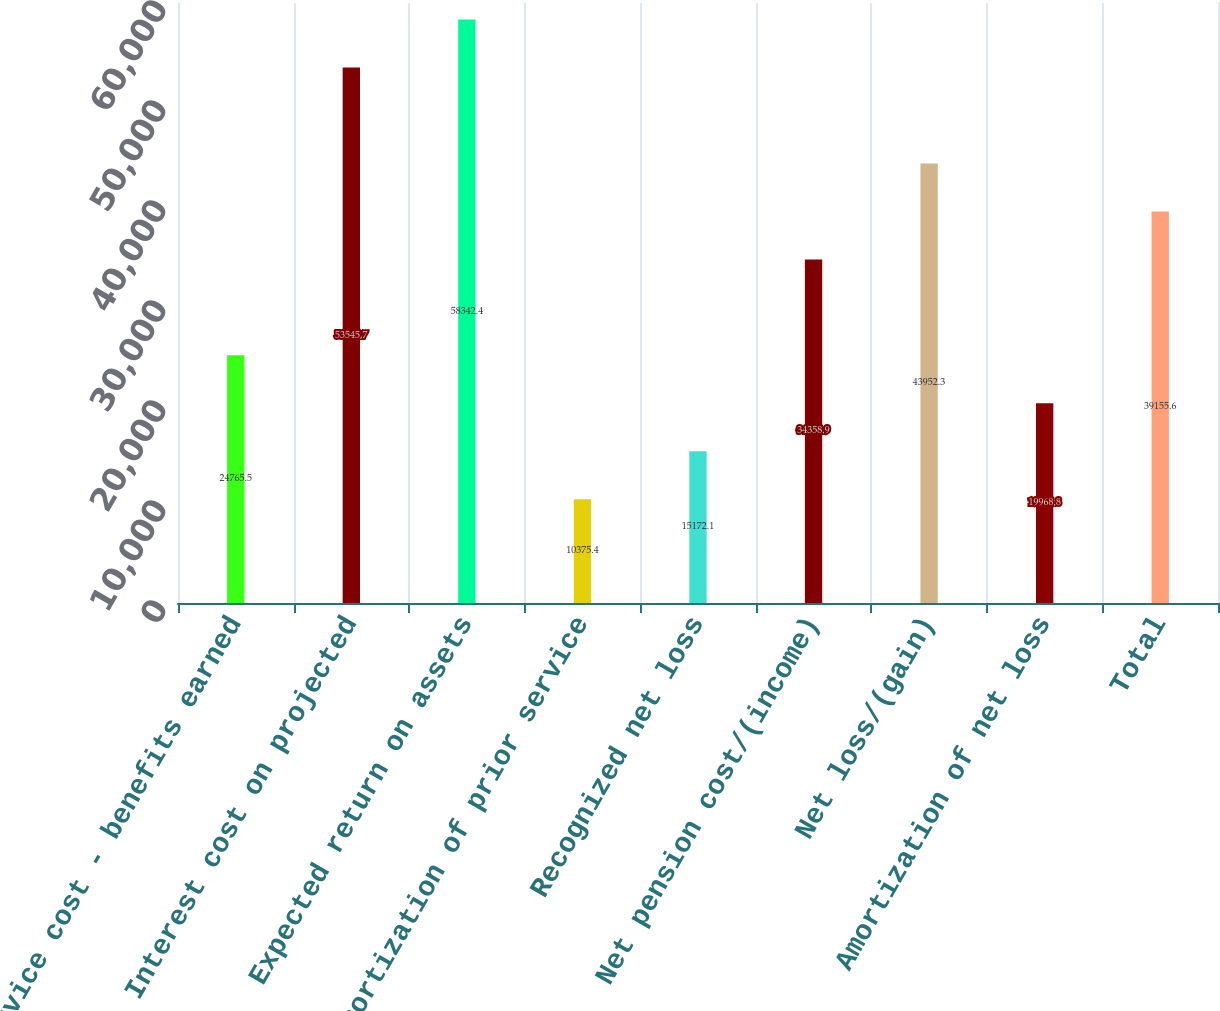<chart> <loc_0><loc_0><loc_500><loc_500><bar_chart><fcel>Service cost - benefits earned<fcel>Interest cost on projected<fcel>Expected return on assets<fcel>Amortization of prior service<fcel>Recognized net loss<fcel>Net pension cost/(income)<fcel>Net loss/(gain)<fcel>Amortization of net loss<fcel>Total<nl><fcel>24765.5<fcel>53545.7<fcel>58342.4<fcel>10375.4<fcel>15172.1<fcel>34358.9<fcel>43952.3<fcel>19968.8<fcel>39155.6<nl></chart> 